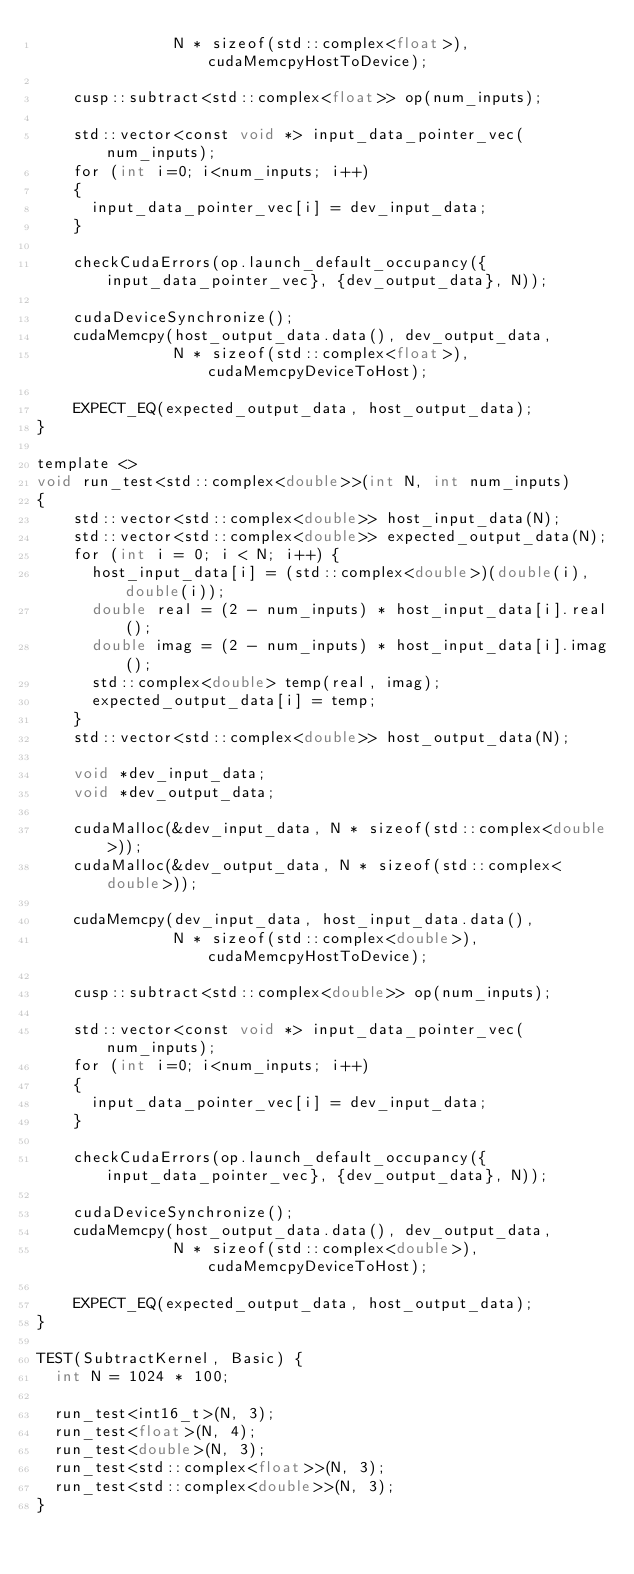<code> <loc_0><loc_0><loc_500><loc_500><_Cuda_>               N * sizeof(std::complex<float>), cudaMemcpyHostToDevice);
  
    cusp::subtract<std::complex<float>> op(num_inputs);

    std::vector<const void *> input_data_pointer_vec(num_inputs);
    for (int i=0; i<num_inputs; i++)
    {
      input_data_pointer_vec[i] = dev_input_data;
    }

    checkCudaErrors(op.launch_default_occupancy({input_data_pointer_vec}, {dev_output_data}, N));
  
    cudaDeviceSynchronize();
    cudaMemcpy(host_output_data.data(), dev_output_data,
               N * sizeof(std::complex<float>), cudaMemcpyDeviceToHost);
  
    EXPECT_EQ(expected_output_data, host_output_data);
}

template <> 
void run_test<std::complex<double>>(int N, int num_inputs)
{
    std::vector<std::complex<double>> host_input_data(N);
    std::vector<std::complex<double>> expected_output_data(N);
    for (int i = 0; i < N; i++) {
      host_input_data[i] = (std::complex<double>)(double(i), double(i));
      double real = (2 - num_inputs) * host_input_data[i].real();
      double imag = (2 - num_inputs) * host_input_data[i].imag();
      std::complex<double> temp(real, imag);
      expected_output_data[i] = temp;
    }
    std::vector<std::complex<double>> host_output_data(N);
  
    void *dev_input_data;
    void *dev_output_data;
  
    cudaMalloc(&dev_input_data, N * sizeof(std::complex<double>));
    cudaMalloc(&dev_output_data, N * sizeof(std::complex<double>));

    cudaMemcpy(dev_input_data, host_input_data.data(),
               N * sizeof(std::complex<double>), cudaMemcpyHostToDevice);
  
    cusp::subtract<std::complex<double>> op(num_inputs);

    std::vector<const void *> input_data_pointer_vec(num_inputs);
    for (int i=0; i<num_inputs; i++)
    {
      input_data_pointer_vec[i] = dev_input_data;
    }

    checkCudaErrors(op.launch_default_occupancy({input_data_pointer_vec}, {dev_output_data}, N));
  
    cudaDeviceSynchronize();
    cudaMemcpy(host_output_data.data(), dev_output_data,
               N * sizeof(std::complex<double>), cudaMemcpyDeviceToHost);
  
    EXPECT_EQ(expected_output_data, host_output_data);
}

TEST(SubtractKernel, Basic) {
  int N = 1024 * 100;

  run_test<int16_t>(N, 3);
  run_test<float>(N, 4);
  run_test<double>(N, 3);
  run_test<std::complex<float>>(N, 3);
  run_test<std::complex<double>>(N, 3);
}</code> 